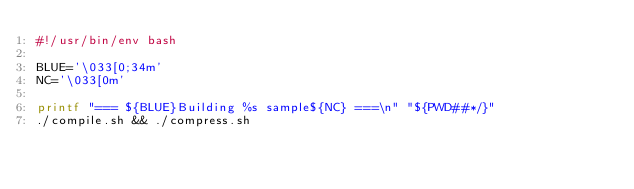<code> <loc_0><loc_0><loc_500><loc_500><_Bash_>#!/usr/bin/env bash

BLUE='\033[0;34m'
NC='\033[0m'

printf "=== ${BLUE}Building %s sample${NC} ===\n" "${PWD##*/}"
./compile.sh && ./compress.sh
</code> 